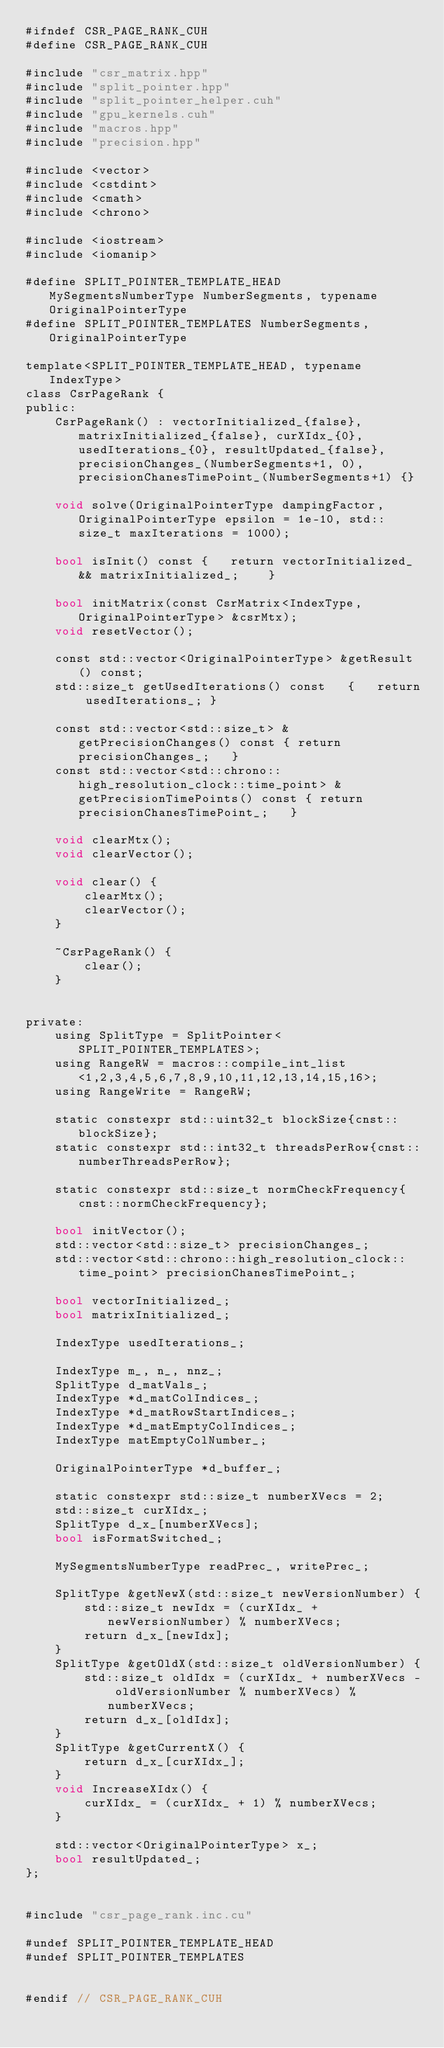<code> <loc_0><loc_0><loc_500><loc_500><_Cuda_>#ifndef CSR_PAGE_RANK_CUH
#define CSR_PAGE_RANK_CUH

#include "csr_matrix.hpp"
#include "split_pointer.hpp"
#include "split_pointer_helper.cuh"
#include "gpu_kernels.cuh"
#include "macros.hpp"
#include "precision.hpp"

#include <vector>
#include <cstdint>
#include <cmath>
#include <chrono>

#include <iostream>
#include <iomanip>

#define SPLIT_POINTER_TEMPLATE_HEAD MySegmentsNumberType NumberSegments, typename OriginalPointerType
#define SPLIT_POINTER_TEMPLATES NumberSegments, OriginalPointerType

template<SPLIT_POINTER_TEMPLATE_HEAD, typename IndexType>
class CsrPageRank {
public:
    CsrPageRank() : vectorInitialized_{false}, matrixInitialized_{false}, curXIdx_{0}, usedIterations_{0}, resultUpdated_{false}, precisionChanges_(NumberSegments+1, 0), precisionChanesTimePoint_(NumberSegments+1) {}
    
    void solve(OriginalPointerType dampingFactor, OriginalPointerType epsilon = 1e-10, std::size_t maxIterations = 1000);
    
    bool isInit() const {   return vectorInitialized_ && matrixInitialized_;    }
    
    bool initMatrix(const CsrMatrix<IndexType, OriginalPointerType> &csrMtx);
    void resetVector();
    
    const std::vector<OriginalPointerType> &getResult() const;
    std::size_t getUsedIterations() const   {   return usedIterations_; }
    
    const std::vector<std::size_t> &getPrecisionChanges() const { return precisionChanges_;   }
    const std::vector<std::chrono::high_resolution_clock::time_point> &getPrecisionTimePoints() const { return precisionChanesTimePoint_;   }
    
    void clearMtx();
    void clearVector();
    
    void clear() {
        clearMtx();
        clearVector();
    }
    
    ~CsrPageRank() {
        clear();
    }

    
private:
    using SplitType = SplitPointer<SPLIT_POINTER_TEMPLATES>;
    using RangeRW = macros::compile_int_list<1,2,3,4,5,6,7,8,9,10,11,12,13,14,15,16>;
    using RangeWrite = RangeRW;
    
    static constexpr std::uint32_t blockSize{cnst::blockSize};
    static constexpr std::int32_t threadsPerRow{cnst::numberThreadsPerRow};
    
    static constexpr std::size_t normCheckFrequency{cnst::normCheckFrequency};
    
    bool initVector();
    std::vector<std::size_t> precisionChanges_;
    std::vector<std::chrono::high_resolution_clock::time_point> precisionChanesTimePoint_;
    
    bool vectorInitialized_;
    bool matrixInitialized_;
    
    IndexType usedIterations_;
    
    IndexType m_, n_, nnz_;
    SplitType d_matVals_;
    IndexType *d_matColIndices_;
    IndexType *d_matRowStartIndices_;
    IndexType *d_matEmptyColIndices_;
    IndexType matEmptyColNumber_;

    OriginalPointerType *d_buffer_;
    
    static constexpr std::size_t numberXVecs = 2;
    std::size_t curXIdx_;
    SplitType d_x_[numberXVecs];
    bool isFormatSwitched_;
    
    MySegmentsNumberType readPrec_, writePrec_;
    
    SplitType &getNewX(std::size_t newVersionNumber) {
        std::size_t newIdx = (curXIdx_ + newVersionNumber) % numberXVecs;
        return d_x_[newIdx];
    }
    SplitType &getOldX(std::size_t oldVersionNumber) {
        std::size_t oldIdx = (curXIdx_ + numberXVecs - oldVersionNumber % numberXVecs) % numberXVecs;
        return d_x_[oldIdx];
    }
    SplitType &getCurrentX() {
        return d_x_[curXIdx_];
    }
    void IncreaseXIdx() {
        curXIdx_ = (curXIdx_ + 1) % numberXVecs;
    }
    
    std::vector<OriginalPointerType> x_;
    bool resultUpdated_;
};


#include "csr_page_rank.inc.cu"

#undef SPLIT_POINTER_TEMPLATE_HEAD
#undef SPLIT_POINTER_TEMPLATES


#endif // CSR_PAGE_RANK_CUH
</code> 